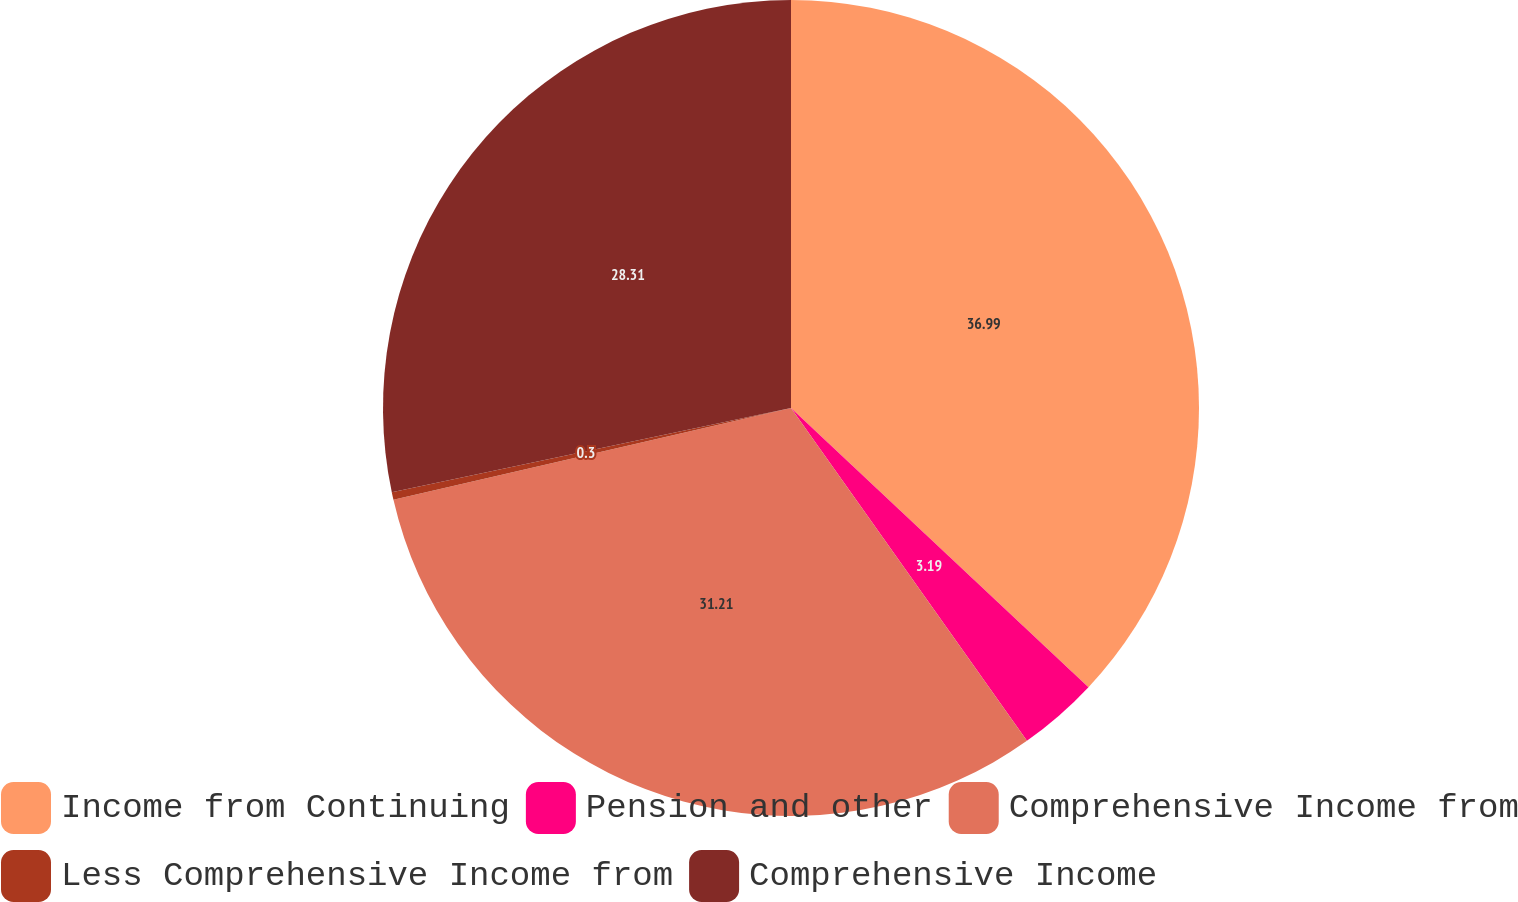<chart> <loc_0><loc_0><loc_500><loc_500><pie_chart><fcel>Income from Continuing<fcel>Pension and other<fcel>Comprehensive Income from<fcel>Less Comprehensive Income from<fcel>Comprehensive Income<nl><fcel>37.0%<fcel>3.19%<fcel>31.21%<fcel>0.3%<fcel>28.31%<nl></chart> 